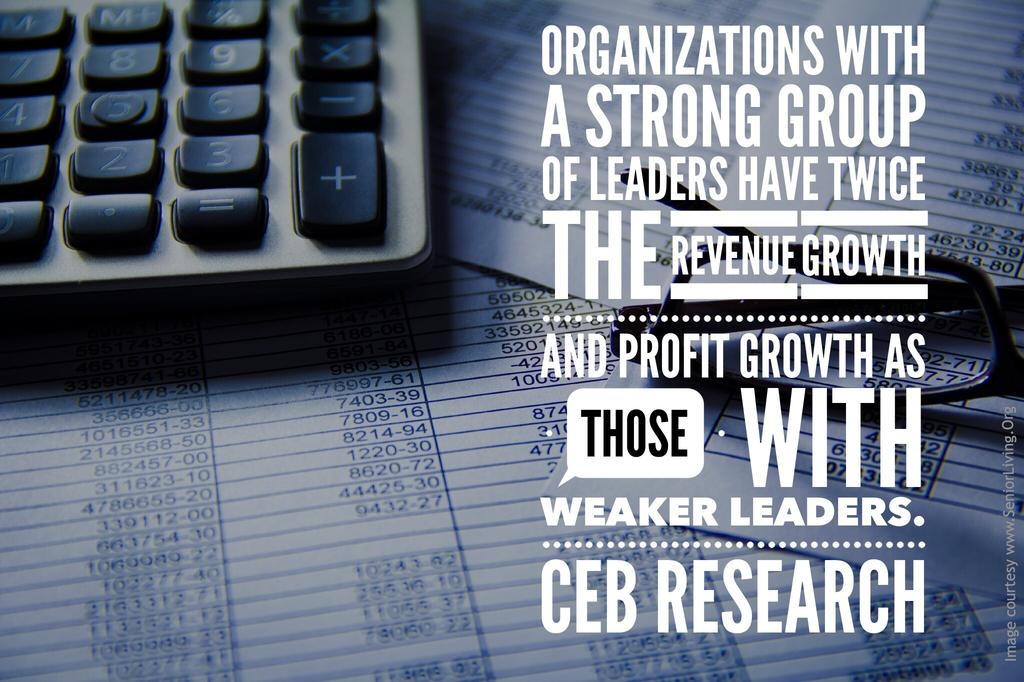<image>
Summarize the visual content of the image. a black and white poster for ceb research 